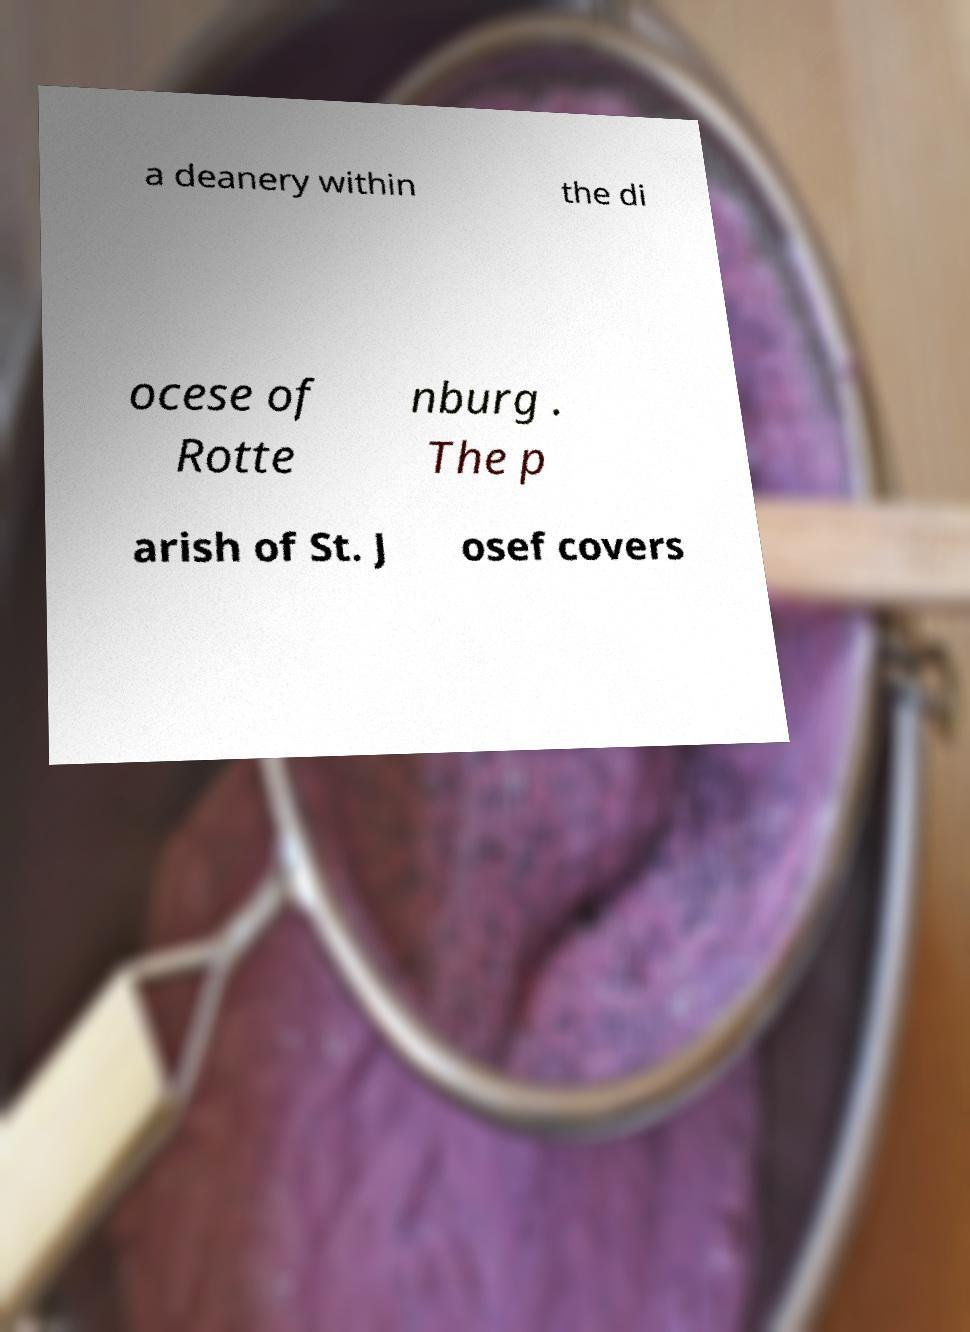Could you assist in decoding the text presented in this image and type it out clearly? a deanery within the di ocese of Rotte nburg . The p arish of St. J osef covers 